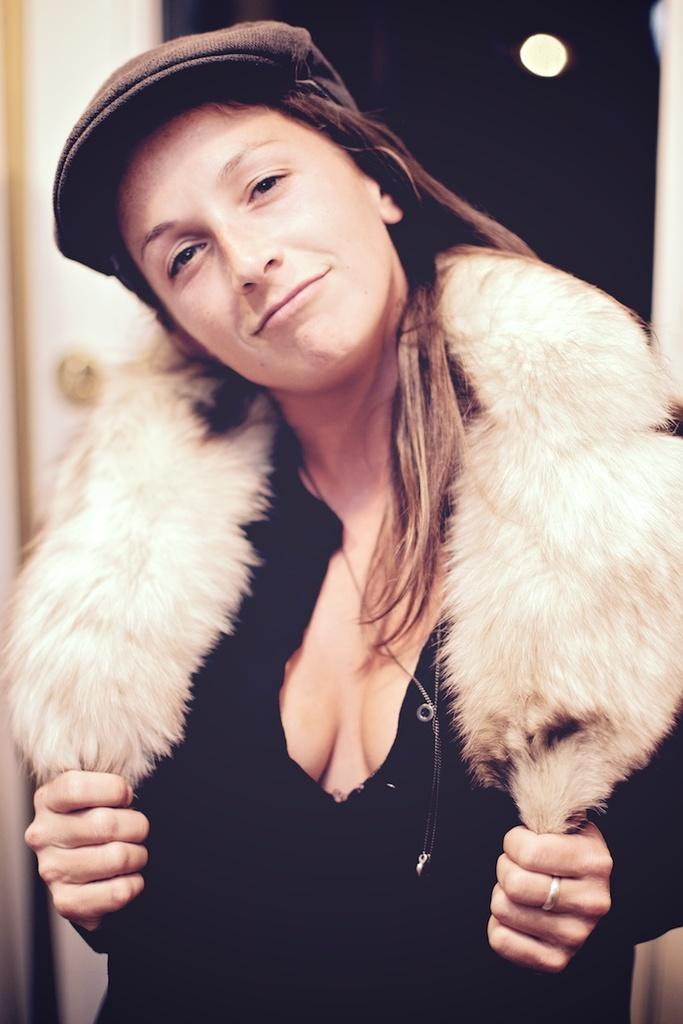Who is present in the image? There is a woman in the image. What is the woman's facial expression? The woman is smiling. What is the woman wearing on her head? The woman is wearing a hat. What can be seen in the background of the image? There is a wall in the background of the image. What is the color of the wall? The wall is white in color. What type of bells can be heard ringing in the image? There are no bells present in the image, and therefore no sound can be heard. 